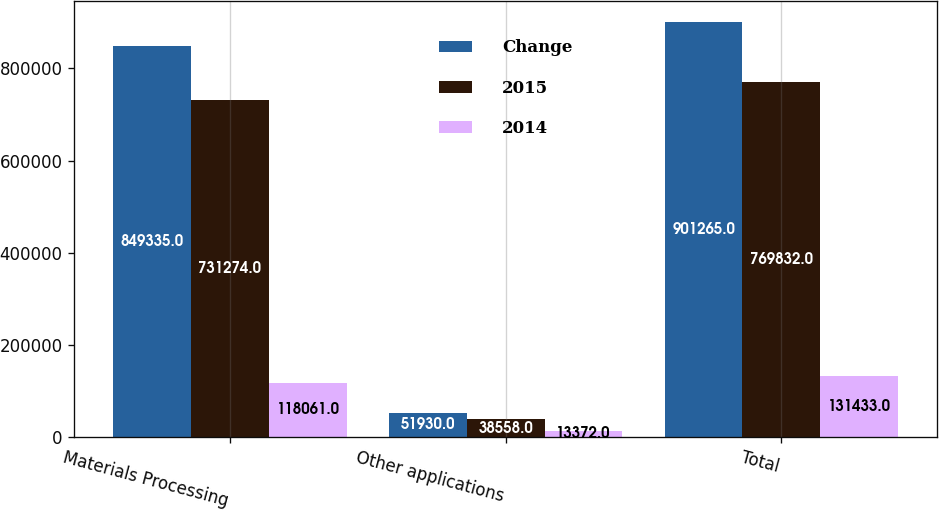Convert chart. <chart><loc_0><loc_0><loc_500><loc_500><stacked_bar_chart><ecel><fcel>Materials Processing<fcel>Other applications<fcel>Total<nl><fcel>Change<fcel>849335<fcel>51930<fcel>901265<nl><fcel>2015<fcel>731274<fcel>38558<fcel>769832<nl><fcel>2014<fcel>118061<fcel>13372<fcel>131433<nl></chart> 